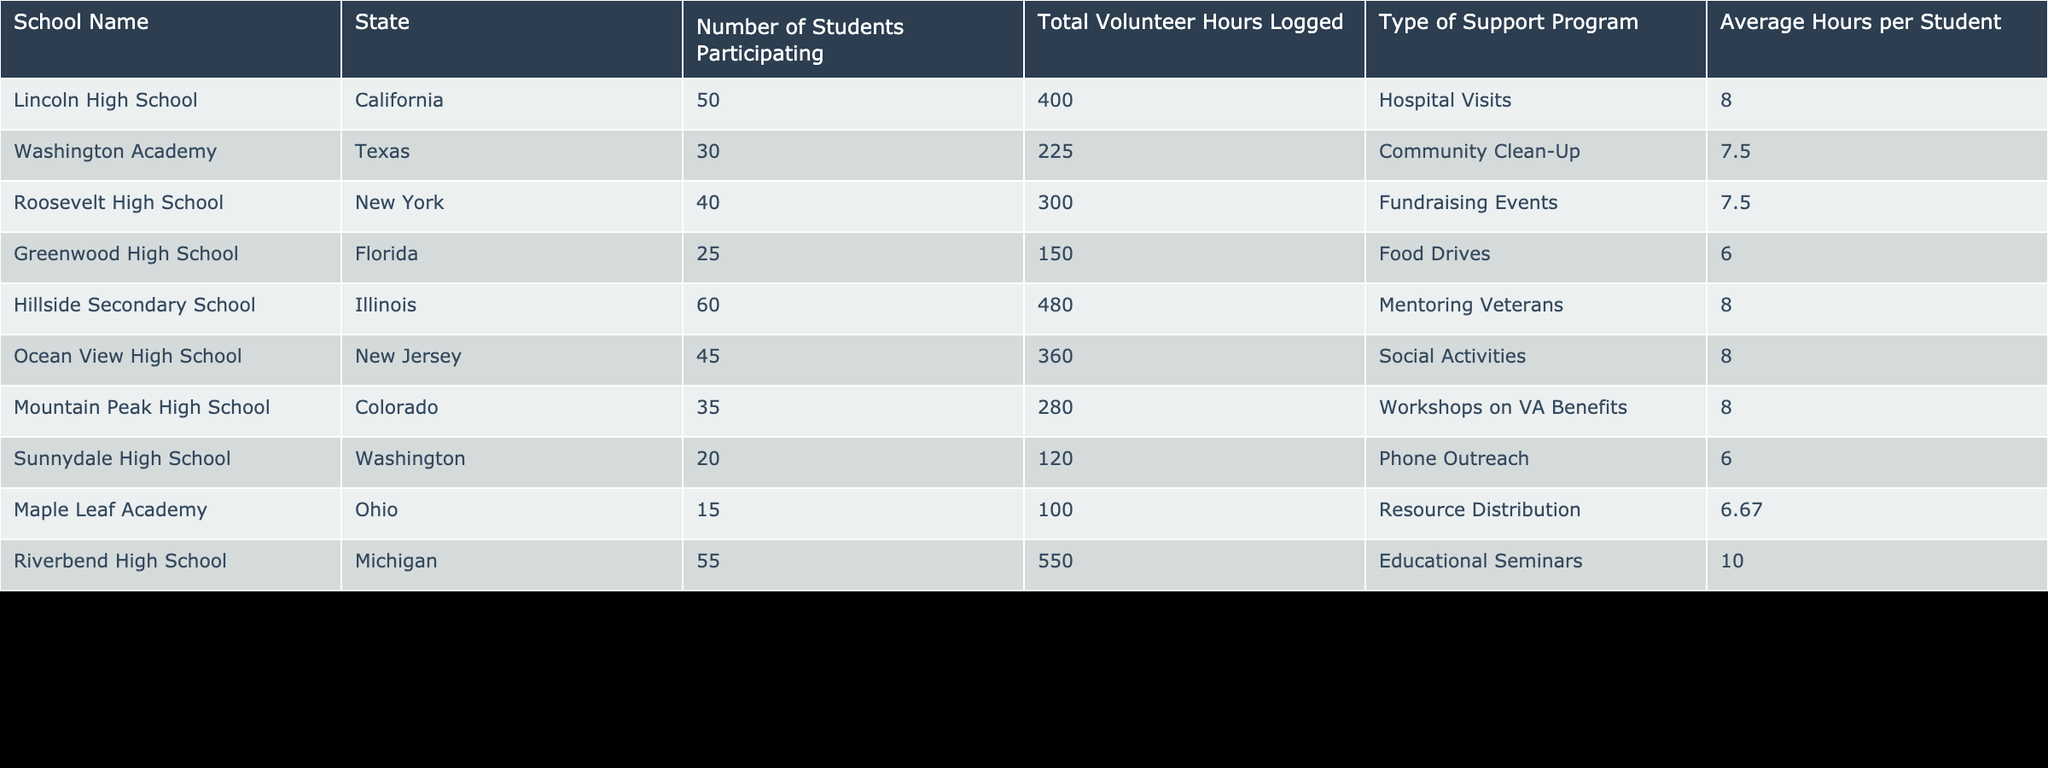What is the total volunteer hours logged by Riverbend High School? The table shows a specific entry for Riverbend High School, which has logged a total of 550 volunteer hours. This information is straightforwardly listed in the “Total Volunteer Hours Logged” column.
Answer: 550 What is the average hours per student for Ocean View High School? The table lists Ocean View High School's average hours per student in the “Average Hours per Student” column, which is 8.
Answer: 8 Which school logged the least total volunteer hours? By examining the “Total Volunteer Hours Logged” column, Greenwood High School shows the least at 150 hours, making it the school with the minimum logged hours.
Answer: Greenwood High School Is the participation at Washington Academy equal to the participation at Lincoln High School? At Washington Academy, the number of students participating is 30, while at Lincoln High School, it is 50. Since these values are not the same, the answer is no.
Answer: No What is the total number of students participating across all schools? To find the total participation, add the number of students from all schools: 50 + 30 + 40 + 25 + 60 + 45 + 35 + 20 + 15 + 55 =  410. Therefore, the total number of students participating is 410.
Answer: 410 Which type of support program had the highest average hours per student? The table lists the average hours per student for all support programs. By comparing these values, Educational Seminars from Riverbend High School has the highest average hours per student at 10.
Answer: Educational Seminars How many schools have logged over 400 total volunteer hours? From the table, we can count the schools with total volunteer hours exceeding 400: Riverbend High School (550), Hillside Secondary School (480), and Lincoln High School (400). This results in three schools exceeding this threshold.
Answer: 3 What is the difference in average hours per student between the food drives and mentoring veterans? From the table, Food Drives logged an average of 6 hours per student, while Mentoring Veterans logged 8 hours per student. The difference is calculated as 8 - 6 = 2.
Answer: 2 Is there any school that logged more than 400 total volunteer hours and has an average hour per student of at least 8? Looking at the table, Hillside Secondary School (480 hours, 8 hours per student) and Riverbend High School (550 hours, 10 hours per student) meet these criteria. Therefore, the answer is yes.
Answer: Yes 